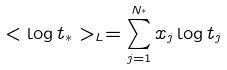<formula> <loc_0><loc_0><loc_500><loc_500>< \log t _ { \ast } > _ { L } = \sum _ { j = 1 } ^ { N _ { ^ { * } } } x _ { j } \log t _ { j }</formula> 